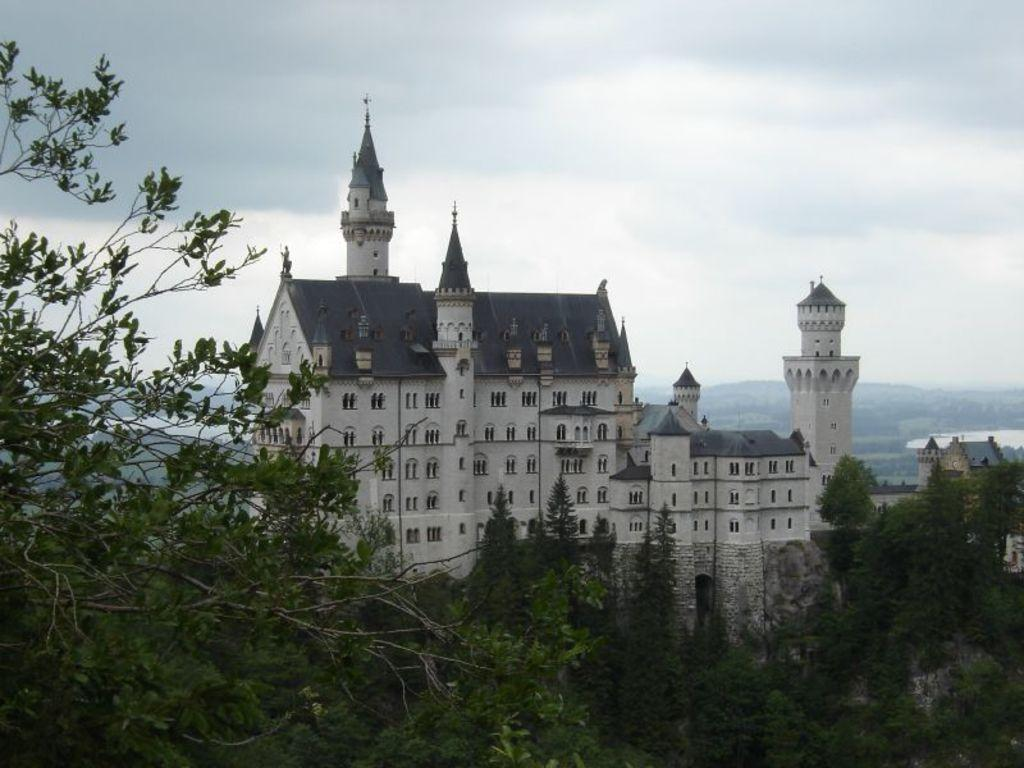What type of structures can be seen in the image? There are buildings in the image. What type of vegetation is present in the image? There are trees in the image. What part of the natural environment is visible in the image? The sky is visible in the background of the image. Can you see a chicken kissing a tree in the image? There is no chicken or any indication of a kiss in the image; it features buildings, trees, and the sky. 